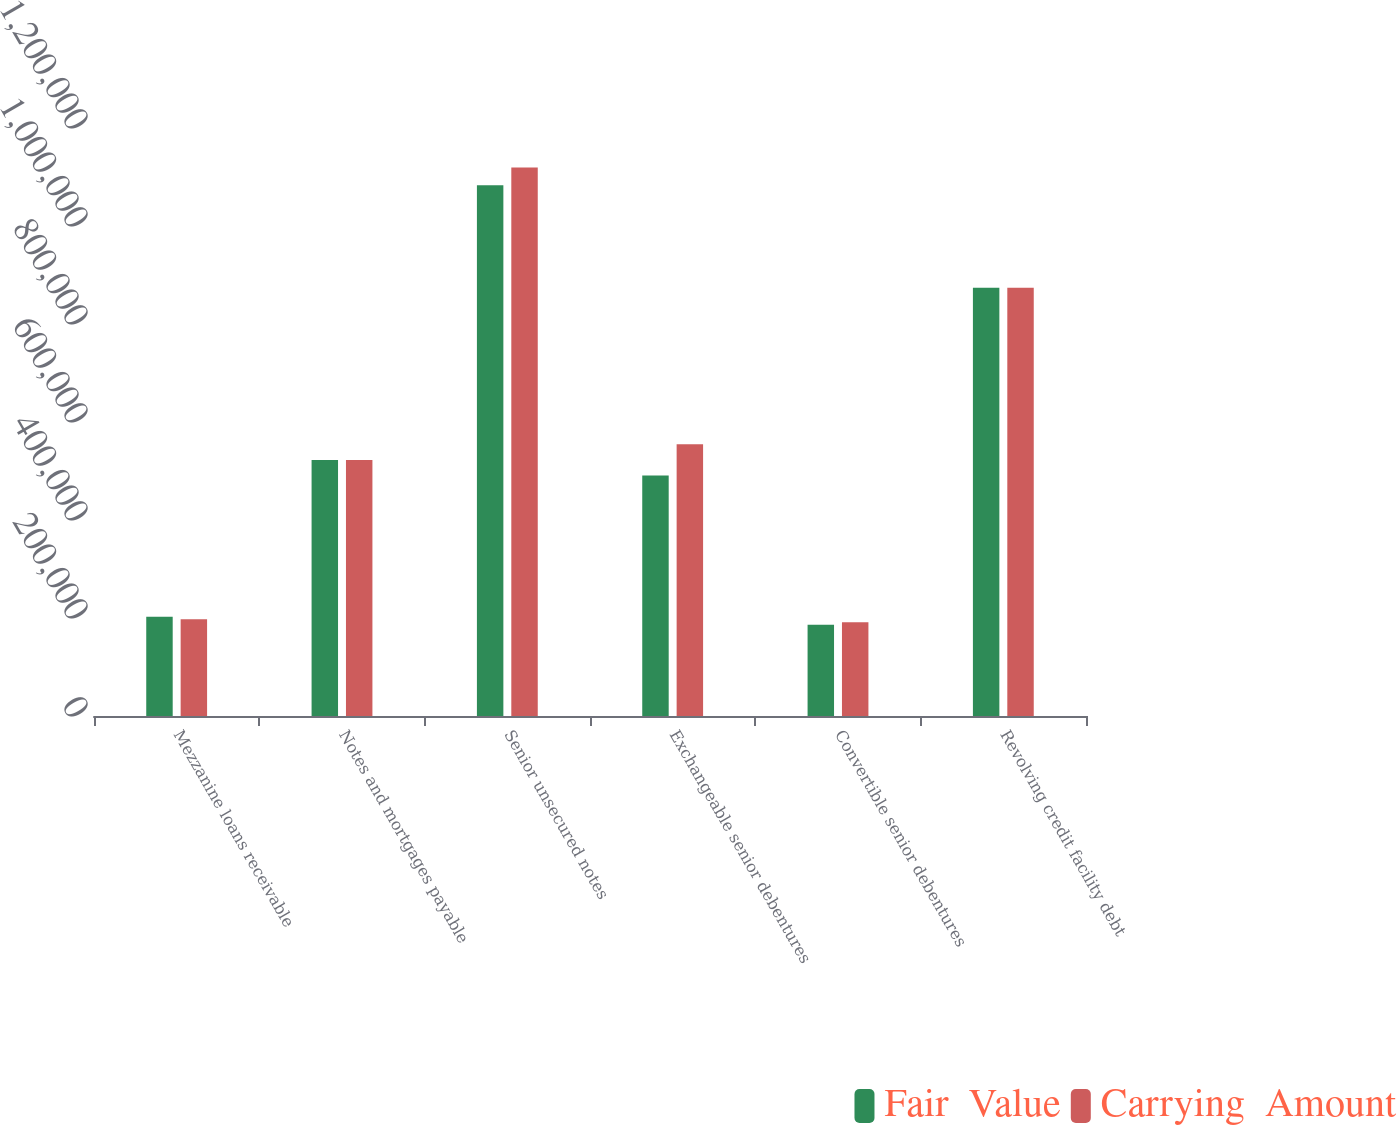Convert chart to OTSL. <chart><loc_0><loc_0><loc_500><loc_500><stacked_bar_chart><ecel><fcel>Mezzanine loans receivable<fcel>Notes and mortgages payable<fcel>Senior unsecured notes<fcel>Exchangeable senior debentures<fcel>Convertible senior debentures<fcel>Revolving credit facility debt<nl><fcel>Fair  Value<fcel>202412<fcel>522678<fcel>1.08293e+06<fcel>491000<fcel>186413<fcel>874000<nl><fcel>Carrying  Amount<fcel>197581<fcel>522678<fcel>1.11951e+06<fcel>554355<fcel>191510<fcel>874000<nl></chart> 